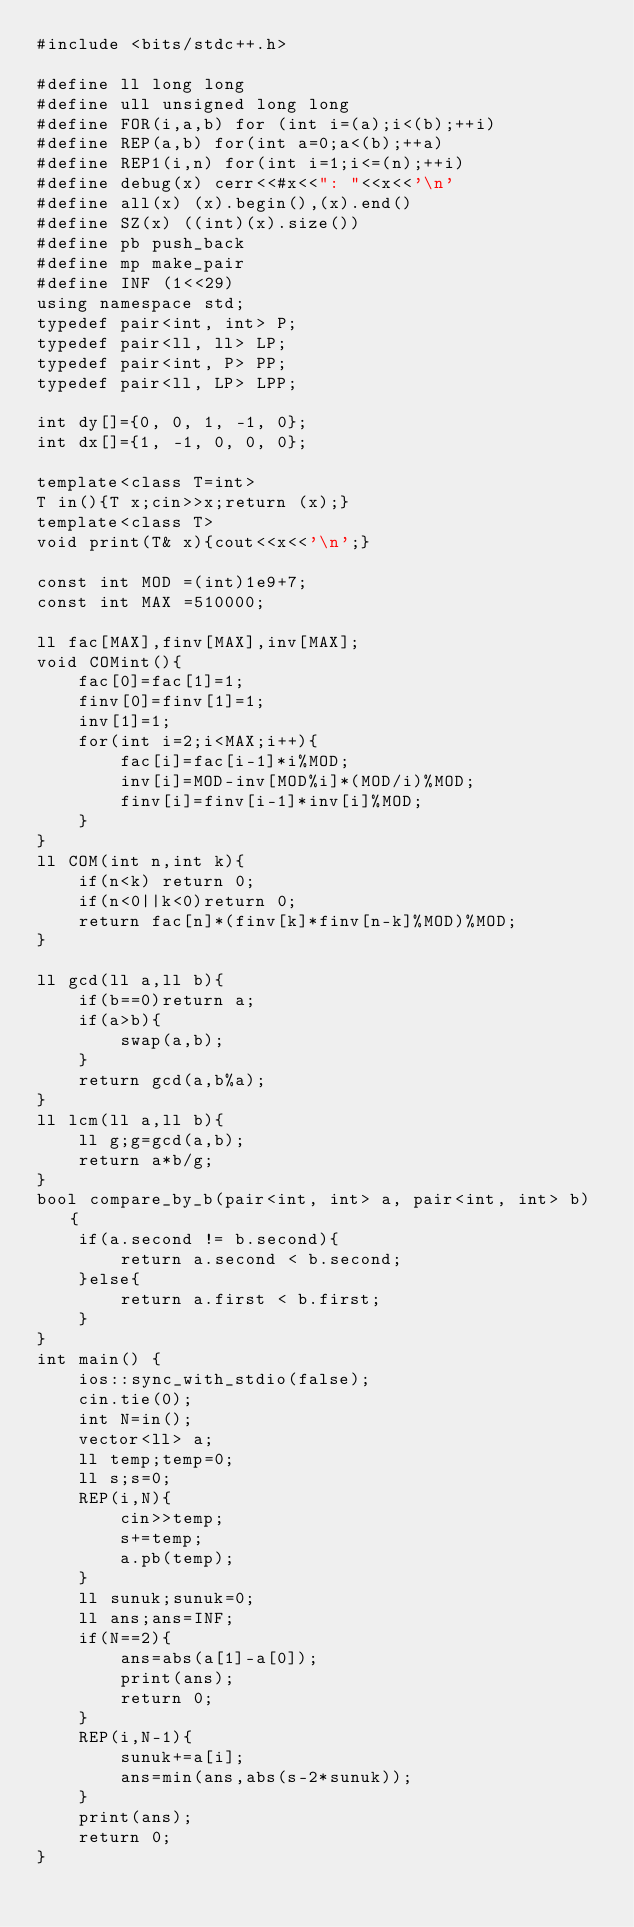Convert code to text. <code><loc_0><loc_0><loc_500><loc_500><_C++_>#include <bits/stdc++.h>

#define ll long long
#define ull unsigned long long
#define FOR(i,a,b) for (int i=(a);i<(b);++i)
#define REP(a,b) for(int a=0;a<(b);++a)
#define REP1(i,n) for(int i=1;i<=(n);++i)
#define debug(x) cerr<<#x<<": "<<x<<'\n'
#define all(x) (x).begin(),(x).end()
#define SZ(x) ((int)(x).size())
#define pb push_back
#define mp make_pair
#define INF (1<<29)
using namespace std;
typedef pair<int, int> P;
typedef pair<ll, ll> LP;
typedef pair<int, P> PP;
typedef pair<ll, LP> LPP;

int dy[]={0, 0, 1, -1, 0};
int dx[]={1, -1, 0, 0, 0};

template<class T=int>
T in(){T x;cin>>x;return (x);}
template<class T>
void print(T& x){cout<<x<<'\n';}

const int MOD =(int)1e9+7;
const int MAX =510000;

ll fac[MAX],finv[MAX],inv[MAX];
void COMint(){
    fac[0]=fac[1]=1;
    finv[0]=finv[1]=1;
    inv[1]=1;
    for(int i=2;i<MAX;i++){
        fac[i]=fac[i-1]*i%MOD;
        inv[i]=MOD-inv[MOD%i]*(MOD/i)%MOD;
        finv[i]=finv[i-1]*inv[i]%MOD;
    }
}
ll COM(int n,int k){
    if(n<k) return 0;
    if(n<0||k<0)return 0;
    return fac[n]*(finv[k]*finv[n-k]%MOD)%MOD;
}

ll gcd(ll a,ll b){
    if(b==0)return a;
    if(a>b){
        swap(a,b);
    }
    return gcd(a,b%a);
}
ll lcm(ll a,ll b){
    ll g;g=gcd(a,b);
    return a*b/g;
}
bool compare_by_b(pair<int, int> a, pair<int, int> b) {
    if(a.second != b.second){
        return a.second < b.second;
    }else{
        return a.first < b.first;
    }
}
int main() {
    ios::sync_with_stdio(false);
    cin.tie(0);
    int N=in();
    vector<ll> a;
    ll temp;temp=0;
    ll s;s=0;
    REP(i,N){
        cin>>temp;
        s+=temp;
        a.pb(temp);
    }
    ll sunuk;sunuk=0;
    ll ans;ans=INF;
    if(N==2){
        ans=abs(a[1]-a[0]);
        print(ans);
        return 0;
    }
    REP(i,N-1){
        sunuk+=a[i];
        ans=min(ans,abs(s-2*sunuk));
    }
    print(ans);
    return 0;
}</code> 